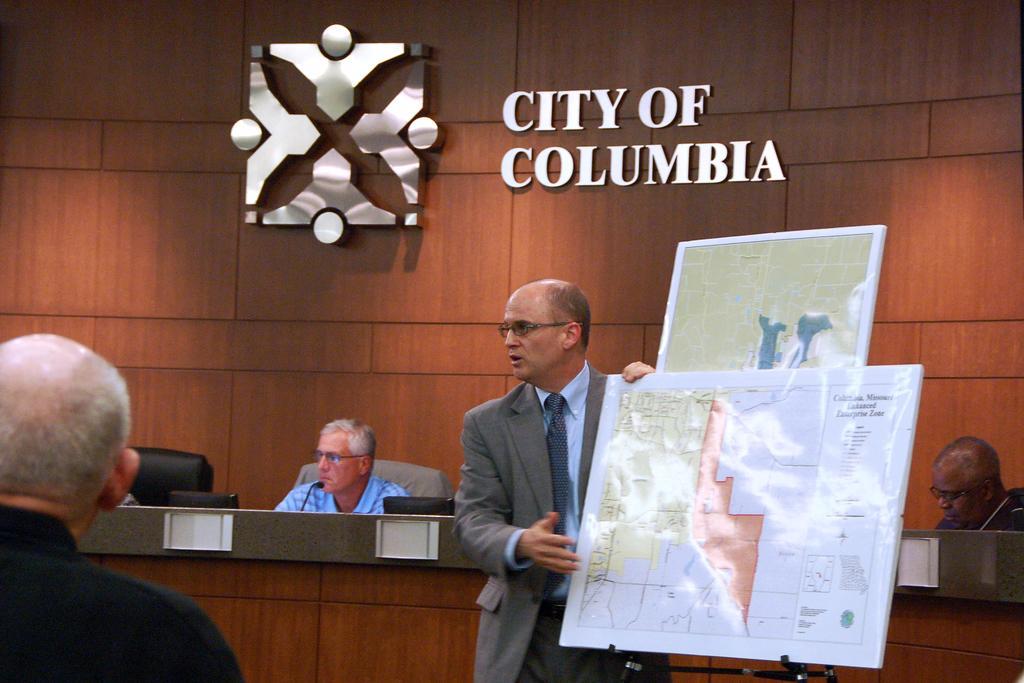Can you describe this image briefly? This picture seems to be clicked inside the hall. On the right we can see a person wearing suit and standing and we can see the text and some pictures on the boards and we can see the metal stand. On the left corner we can see a person. In the background we can see the text and some pictures on the wall, we can see the two persons sitting on the chairs, we can see the microphone, chair and some other objects. 